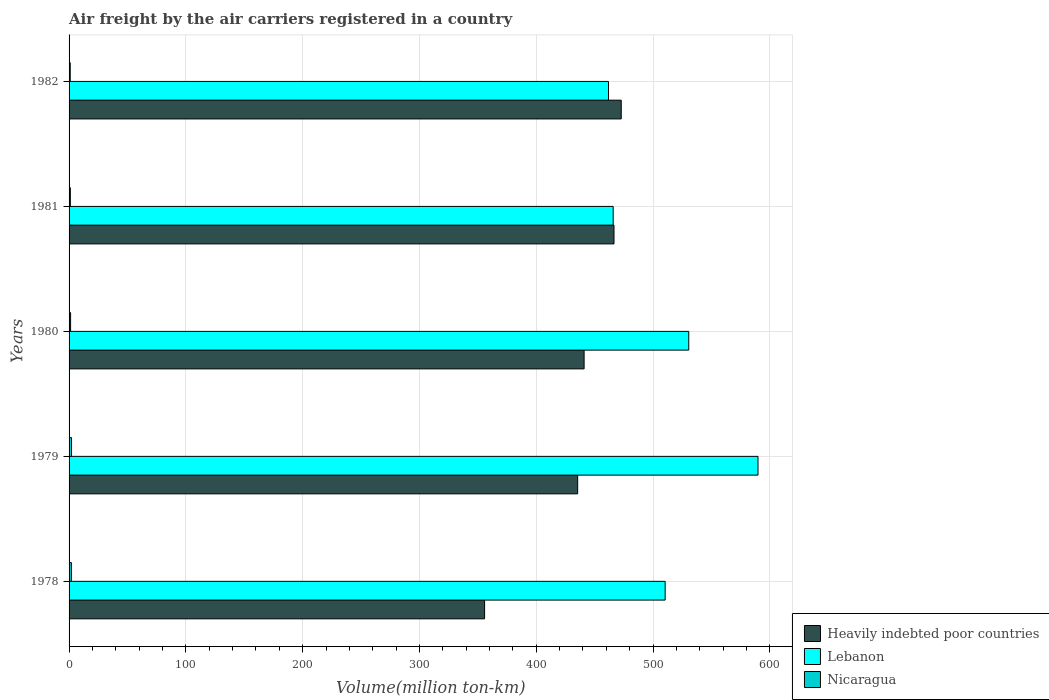How many groups of bars are there?
Provide a short and direct response. 5. Are the number of bars per tick equal to the number of legend labels?
Your answer should be very brief. Yes. How many bars are there on the 2nd tick from the bottom?
Provide a short and direct response. 3. In how many cases, is the number of bars for a given year not equal to the number of legend labels?
Offer a terse response. 0. Across all years, what is the maximum volume of the air carriers in Heavily indebted poor countries?
Provide a succinct answer. 472.8. Across all years, what is the minimum volume of the air carriers in Nicaragua?
Provide a succinct answer. 1. In which year was the volume of the air carriers in Lebanon maximum?
Ensure brevity in your answer.  1979. In which year was the volume of the air carriers in Nicaragua minimum?
Your response must be concise. 1982. What is the total volume of the air carriers in Lebanon in the graph?
Offer a terse response. 2558.7. What is the difference between the volume of the air carriers in Nicaragua in 1978 and that in 1981?
Your answer should be compact. 0.9. What is the difference between the volume of the air carriers in Nicaragua in 1980 and the volume of the air carriers in Heavily indebted poor countries in 1979?
Provide a succinct answer. -434.2. What is the average volume of the air carriers in Lebanon per year?
Your response must be concise. 511.74. In the year 1981, what is the difference between the volume of the air carriers in Lebanon and volume of the air carriers in Heavily indebted poor countries?
Offer a terse response. -0.7. In how many years, is the volume of the air carriers in Lebanon greater than 200 million ton-km?
Provide a succinct answer. 5. What is the ratio of the volume of the air carriers in Nicaragua in 1980 to that in 1982?
Provide a short and direct response. 1.3. Is the volume of the air carriers in Heavily indebted poor countries in 1978 less than that in 1979?
Ensure brevity in your answer.  Yes. Is the difference between the volume of the air carriers in Lebanon in 1981 and 1982 greater than the difference between the volume of the air carriers in Heavily indebted poor countries in 1981 and 1982?
Your response must be concise. Yes. What is the difference between the highest and the second highest volume of the air carriers in Nicaragua?
Provide a succinct answer. 0.1. What is the difference between the highest and the lowest volume of the air carriers in Heavily indebted poor countries?
Provide a succinct answer. 117. In how many years, is the volume of the air carriers in Nicaragua greater than the average volume of the air carriers in Nicaragua taken over all years?
Provide a succinct answer. 2. Is the sum of the volume of the air carriers in Heavily indebted poor countries in 1978 and 1982 greater than the maximum volume of the air carriers in Lebanon across all years?
Provide a succinct answer. Yes. What does the 1st bar from the top in 1981 represents?
Offer a terse response. Nicaragua. What does the 3rd bar from the bottom in 1978 represents?
Provide a succinct answer. Nicaragua. How many bars are there?
Provide a short and direct response. 15. What is the difference between two consecutive major ticks on the X-axis?
Make the answer very short. 100. Are the values on the major ticks of X-axis written in scientific E-notation?
Offer a terse response. No. Does the graph contain any zero values?
Your response must be concise. No. Does the graph contain grids?
Ensure brevity in your answer.  Yes. How are the legend labels stacked?
Offer a terse response. Vertical. What is the title of the graph?
Ensure brevity in your answer.  Air freight by the air carriers registered in a country. What is the label or title of the X-axis?
Make the answer very short. Volume(million ton-km). What is the Volume(million ton-km) of Heavily indebted poor countries in 1978?
Provide a short and direct response. 355.8. What is the Volume(million ton-km) in Lebanon in 1978?
Ensure brevity in your answer.  510.4. What is the Volume(million ton-km) in Nicaragua in 1978?
Offer a very short reply. 2. What is the Volume(million ton-km) in Heavily indebted poor countries in 1979?
Offer a terse response. 435.5. What is the Volume(million ton-km) of Lebanon in 1979?
Make the answer very short. 589.9. What is the Volume(million ton-km) in Nicaragua in 1979?
Provide a succinct answer. 2.1. What is the Volume(million ton-km) of Heavily indebted poor countries in 1980?
Offer a very short reply. 441. What is the Volume(million ton-km) of Lebanon in 1980?
Offer a terse response. 530.6. What is the Volume(million ton-km) of Nicaragua in 1980?
Offer a terse response. 1.3. What is the Volume(million ton-km) of Heavily indebted poor countries in 1981?
Your answer should be compact. 466.6. What is the Volume(million ton-km) of Lebanon in 1981?
Offer a terse response. 465.9. What is the Volume(million ton-km) in Nicaragua in 1981?
Ensure brevity in your answer.  1.1. What is the Volume(million ton-km) in Heavily indebted poor countries in 1982?
Your answer should be very brief. 472.8. What is the Volume(million ton-km) in Lebanon in 1982?
Make the answer very short. 461.9. What is the Volume(million ton-km) in Nicaragua in 1982?
Provide a short and direct response. 1. Across all years, what is the maximum Volume(million ton-km) in Heavily indebted poor countries?
Ensure brevity in your answer.  472.8. Across all years, what is the maximum Volume(million ton-km) in Lebanon?
Your answer should be very brief. 589.9. Across all years, what is the maximum Volume(million ton-km) in Nicaragua?
Give a very brief answer. 2.1. Across all years, what is the minimum Volume(million ton-km) of Heavily indebted poor countries?
Offer a very short reply. 355.8. Across all years, what is the minimum Volume(million ton-km) in Lebanon?
Your answer should be compact. 461.9. Across all years, what is the minimum Volume(million ton-km) of Nicaragua?
Provide a succinct answer. 1. What is the total Volume(million ton-km) of Heavily indebted poor countries in the graph?
Offer a very short reply. 2171.7. What is the total Volume(million ton-km) of Lebanon in the graph?
Offer a very short reply. 2558.7. What is the difference between the Volume(million ton-km) in Heavily indebted poor countries in 1978 and that in 1979?
Keep it short and to the point. -79.7. What is the difference between the Volume(million ton-km) in Lebanon in 1978 and that in 1979?
Give a very brief answer. -79.5. What is the difference between the Volume(million ton-km) in Heavily indebted poor countries in 1978 and that in 1980?
Your answer should be very brief. -85.2. What is the difference between the Volume(million ton-km) in Lebanon in 1978 and that in 1980?
Keep it short and to the point. -20.2. What is the difference between the Volume(million ton-km) of Heavily indebted poor countries in 1978 and that in 1981?
Your answer should be very brief. -110.8. What is the difference between the Volume(million ton-km) of Lebanon in 1978 and that in 1981?
Your answer should be very brief. 44.5. What is the difference between the Volume(million ton-km) of Heavily indebted poor countries in 1978 and that in 1982?
Provide a short and direct response. -117. What is the difference between the Volume(million ton-km) in Lebanon in 1978 and that in 1982?
Your answer should be very brief. 48.5. What is the difference between the Volume(million ton-km) in Nicaragua in 1978 and that in 1982?
Provide a short and direct response. 1. What is the difference between the Volume(million ton-km) of Heavily indebted poor countries in 1979 and that in 1980?
Your answer should be compact. -5.5. What is the difference between the Volume(million ton-km) in Lebanon in 1979 and that in 1980?
Provide a short and direct response. 59.3. What is the difference between the Volume(million ton-km) in Nicaragua in 1979 and that in 1980?
Ensure brevity in your answer.  0.8. What is the difference between the Volume(million ton-km) of Heavily indebted poor countries in 1979 and that in 1981?
Your answer should be compact. -31.1. What is the difference between the Volume(million ton-km) in Lebanon in 1979 and that in 1981?
Offer a very short reply. 124. What is the difference between the Volume(million ton-km) in Heavily indebted poor countries in 1979 and that in 1982?
Your answer should be very brief. -37.3. What is the difference between the Volume(million ton-km) of Lebanon in 1979 and that in 1982?
Provide a succinct answer. 128. What is the difference between the Volume(million ton-km) in Heavily indebted poor countries in 1980 and that in 1981?
Your answer should be compact. -25.6. What is the difference between the Volume(million ton-km) in Lebanon in 1980 and that in 1981?
Provide a short and direct response. 64.7. What is the difference between the Volume(million ton-km) of Nicaragua in 1980 and that in 1981?
Make the answer very short. 0.2. What is the difference between the Volume(million ton-km) in Heavily indebted poor countries in 1980 and that in 1982?
Provide a succinct answer. -31.8. What is the difference between the Volume(million ton-km) in Lebanon in 1980 and that in 1982?
Your answer should be very brief. 68.7. What is the difference between the Volume(million ton-km) of Nicaragua in 1980 and that in 1982?
Keep it short and to the point. 0.3. What is the difference between the Volume(million ton-km) of Heavily indebted poor countries in 1981 and that in 1982?
Give a very brief answer. -6.2. What is the difference between the Volume(million ton-km) in Nicaragua in 1981 and that in 1982?
Offer a terse response. 0.1. What is the difference between the Volume(million ton-km) in Heavily indebted poor countries in 1978 and the Volume(million ton-km) in Lebanon in 1979?
Your answer should be very brief. -234.1. What is the difference between the Volume(million ton-km) in Heavily indebted poor countries in 1978 and the Volume(million ton-km) in Nicaragua in 1979?
Ensure brevity in your answer.  353.7. What is the difference between the Volume(million ton-km) in Lebanon in 1978 and the Volume(million ton-km) in Nicaragua in 1979?
Offer a terse response. 508.3. What is the difference between the Volume(million ton-km) in Heavily indebted poor countries in 1978 and the Volume(million ton-km) in Lebanon in 1980?
Your answer should be compact. -174.8. What is the difference between the Volume(million ton-km) of Heavily indebted poor countries in 1978 and the Volume(million ton-km) of Nicaragua in 1980?
Make the answer very short. 354.5. What is the difference between the Volume(million ton-km) of Lebanon in 1978 and the Volume(million ton-km) of Nicaragua in 1980?
Keep it short and to the point. 509.1. What is the difference between the Volume(million ton-km) of Heavily indebted poor countries in 1978 and the Volume(million ton-km) of Lebanon in 1981?
Give a very brief answer. -110.1. What is the difference between the Volume(million ton-km) of Heavily indebted poor countries in 1978 and the Volume(million ton-km) of Nicaragua in 1981?
Provide a succinct answer. 354.7. What is the difference between the Volume(million ton-km) of Lebanon in 1978 and the Volume(million ton-km) of Nicaragua in 1981?
Ensure brevity in your answer.  509.3. What is the difference between the Volume(million ton-km) of Heavily indebted poor countries in 1978 and the Volume(million ton-km) of Lebanon in 1982?
Your answer should be very brief. -106.1. What is the difference between the Volume(million ton-km) in Heavily indebted poor countries in 1978 and the Volume(million ton-km) in Nicaragua in 1982?
Offer a very short reply. 354.8. What is the difference between the Volume(million ton-km) of Lebanon in 1978 and the Volume(million ton-km) of Nicaragua in 1982?
Keep it short and to the point. 509.4. What is the difference between the Volume(million ton-km) in Heavily indebted poor countries in 1979 and the Volume(million ton-km) in Lebanon in 1980?
Provide a succinct answer. -95.1. What is the difference between the Volume(million ton-km) in Heavily indebted poor countries in 1979 and the Volume(million ton-km) in Nicaragua in 1980?
Your answer should be very brief. 434.2. What is the difference between the Volume(million ton-km) of Lebanon in 1979 and the Volume(million ton-km) of Nicaragua in 1980?
Your response must be concise. 588.6. What is the difference between the Volume(million ton-km) in Heavily indebted poor countries in 1979 and the Volume(million ton-km) in Lebanon in 1981?
Provide a succinct answer. -30.4. What is the difference between the Volume(million ton-km) of Heavily indebted poor countries in 1979 and the Volume(million ton-km) of Nicaragua in 1981?
Make the answer very short. 434.4. What is the difference between the Volume(million ton-km) of Lebanon in 1979 and the Volume(million ton-km) of Nicaragua in 1981?
Provide a short and direct response. 588.8. What is the difference between the Volume(million ton-km) in Heavily indebted poor countries in 1979 and the Volume(million ton-km) in Lebanon in 1982?
Provide a short and direct response. -26.4. What is the difference between the Volume(million ton-km) in Heavily indebted poor countries in 1979 and the Volume(million ton-km) in Nicaragua in 1982?
Provide a succinct answer. 434.5. What is the difference between the Volume(million ton-km) in Lebanon in 1979 and the Volume(million ton-km) in Nicaragua in 1982?
Offer a terse response. 588.9. What is the difference between the Volume(million ton-km) in Heavily indebted poor countries in 1980 and the Volume(million ton-km) in Lebanon in 1981?
Your response must be concise. -24.9. What is the difference between the Volume(million ton-km) of Heavily indebted poor countries in 1980 and the Volume(million ton-km) of Nicaragua in 1981?
Your answer should be very brief. 439.9. What is the difference between the Volume(million ton-km) in Lebanon in 1980 and the Volume(million ton-km) in Nicaragua in 1981?
Your answer should be compact. 529.5. What is the difference between the Volume(million ton-km) in Heavily indebted poor countries in 1980 and the Volume(million ton-km) in Lebanon in 1982?
Provide a short and direct response. -20.9. What is the difference between the Volume(million ton-km) of Heavily indebted poor countries in 1980 and the Volume(million ton-km) of Nicaragua in 1982?
Offer a very short reply. 440. What is the difference between the Volume(million ton-km) of Lebanon in 1980 and the Volume(million ton-km) of Nicaragua in 1982?
Keep it short and to the point. 529.6. What is the difference between the Volume(million ton-km) of Heavily indebted poor countries in 1981 and the Volume(million ton-km) of Lebanon in 1982?
Make the answer very short. 4.7. What is the difference between the Volume(million ton-km) of Heavily indebted poor countries in 1981 and the Volume(million ton-km) of Nicaragua in 1982?
Provide a short and direct response. 465.6. What is the difference between the Volume(million ton-km) in Lebanon in 1981 and the Volume(million ton-km) in Nicaragua in 1982?
Ensure brevity in your answer.  464.9. What is the average Volume(million ton-km) of Heavily indebted poor countries per year?
Provide a short and direct response. 434.34. What is the average Volume(million ton-km) in Lebanon per year?
Offer a very short reply. 511.74. In the year 1978, what is the difference between the Volume(million ton-km) in Heavily indebted poor countries and Volume(million ton-km) in Lebanon?
Provide a succinct answer. -154.6. In the year 1978, what is the difference between the Volume(million ton-km) of Heavily indebted poor countries and Volume(million ton-km) of Nicaragua?
Give a very brief answer. 353.8. In the year 1978, what is the difference between the Volume(million ton-km) of Lebanon and Volume(million ton-km) of Nicaragua?
Offer a terse response. 508.4. In the year 1979, what is the difference between the Volume(million ton-km) in Heavily indebted poor countries and Volume(million ton-km) in Lebanon?
Your answer should be very brief. -154.4. In the year 1979, what is the difference between the Volume(million ton-km) of Heavily indebted poor countries and Volume(million ton-km) of Nicaragua?
Your answer should be compact. 433.4. In the year 1979, what is the difference between the Volume(million ton-km) of Lebanon and Volume(million ton-km) of Nicaragua?
Provide a succinct answer. 587.8. In the year 1980, what is the difference between the Volume(million ton-km) of Heavily indebted poor countries and Volume(million ton-km) of Lebanon?
Give a very brief answer. -89.6. In the year 1980, what is the difference between the Volume(million ton-km) in Heavily indebted poor countries and Volume(million ton-km) in Nicaragua?
Provide a short and direct response. 439.7. In the year 1980, what is the difference between the Volume(million ton-km) of Lebanon and Volume(million ton-km) of Nicaragua?
Keep it short and to the point. 529.3. In the year 1981, what is the difference between the Volume(million ton-km) in Heavily indebted poor countries and Volume(million ton-km) in Nicaragua?
Ensure brevity in your answer.  465.5. In the year 1981, what is the difference between the Volume(million ton-km) of Lebanon and Volume(million ton-km) of Nicaragua?
Give a very brief answer. 464.8. In the year 1982, what is the difference between the Volume(million ton-km) in Heavily indebted poor countries and Volume(million ton-km) in Nicaragua?
Your response must be concise. 471.8. In the year 1982, what is the difference between the Volume(million ton-km) in Lebanon and Volume(million ton-km) in Nicaragua?
Your answer should be very brief. 460.9. What is the ratio of the Volume(million ton-km) in Heavily indebted poor countries in 1978 to that in 1979?
Give a very brief answer. 0.82. What is the ratio of the Volume(million ton-km) of Lebanon in 1978 to that in 1979?
Provide a short and direct response. 0.87. What is the ratio of the Volume(million ton-km) in Nicaragua in 1978 to that in 1979?
Give a very brief answer. 0.95. What is the ratio of the Volume(million ton-km) in Heavily indebted poor countries in 1978 to that in 1980?
Offer a terse response. 0.81. What is the ratio of the Volume(million ton-km) of Lebanon in 1978 to that in 1980?
Provide a short and direct response. 0.96. What is the ratio of the Volume(million ton-km) in Nicaragua in 1978 to that in 1980?
Provide a short and direct response. 1.54. What is the ratio of the Volume(million ton-km) in Heavily indebted poor countries in 1978 to that in 1981?
Provide a succinct answer. 0.76. What is the ratio of the Volume(million ton-km) in Lebanon in 1978 to that in 1981?
Offer a terse response. 1.1. What is the ratio of the Volume(million ton-km) of Nicaragua in 1978 to that in 1981?
Your answer should be very brief. 1.82. What is the ratio of the Volume(million ton-km) in Heavily indebted poor countries in 1978 to that in 1982?
Provide a succinct answer. 0.75. What is the ratio of the Volume(million ton-km) of Lebanon in 1978 to that in 1982?
Offer a terse response. 1.1. What is the ratio of the Volume(million ton-km) of Heavily indebted poor countries in 1979 to that in 1980?
Make the answer very short. 0.99. What is the ratio of the Volume(million ton-km) in Lebanon in 1979 to that in 1980?
Ensure brevity in your answer.  1.11. What is the ratio of the Volume(million ton-km) of Nicaragua in 1979 to that in 1980?
Ensure brevity in your answer.  1.62. What is the ratio of the Volume(million ton-km) in Lebanon in 1979 to that in 1981?
Your answer should be compact. 1.27. What is the ratio of the Volume(million ton-km) in Nicaragua in 1979 to that in 1981?
Offer a very short reply. 1.91. What is the ratio of the Volume(million ton-km) of Heavily indebted poor countries in 1979 to that in 1982?
Your response must be concise. 0.92. What is the ratio of the Volume(million ton-km) of Lebanon in 1979 to that in 1982?
Your answer should be very brief. 1.28. What is the ratio of the Volume(million ton-km) in Heavily indebted poor countries in 1980 to that in 1981?
Provide a succinct answer. 0.95. What is the ratio of the Volume(million ton-km) of Lebanon in 1980 to that in 1981?
Your response must be concise. 1.14. What is the ratio of the Volume(million ton-km) of Nicaragua in 1980 to that in 1981?
Offer a terse response. 1.18. What is the ratio of the Volume(million ton-km) of Heavily indebted poor countries in 1980 to that in 1982?
Your answer should be very brief. 0.93. What is the ratio of the Volume(million ton-km) of Lebanon in 1980 to that in 1982?
Ensure brevity in your answer.  1.15. What is the ratio of the Volume(million ton-km) of Heavily indebted poor countries in 1981 to that in 1982?
Your response must be concise. 0.99. What is the ratio of the Volume(million ton-km) in Lebanon in 1981 to that in 1982?
Provide a short and direct response. 1.01. What is the ratio of the Volume(million ton-km) of Nicaragua in 1981 to that in 1982?
Make the answer very short. 1.1. What is the difference between the highest and the second highest Volume(million ton-km) of Lebanon?
Your answer should be compact. 59.3. What is the difference between the highest and the lowest Volume(million ton-km) of Heavily indebted poor countries?
Provide a short and direct response. 117. What is the difference between the highest and the lowest Volume(million ton-km) in Lebanon?
Offer a very short reply. 128. 